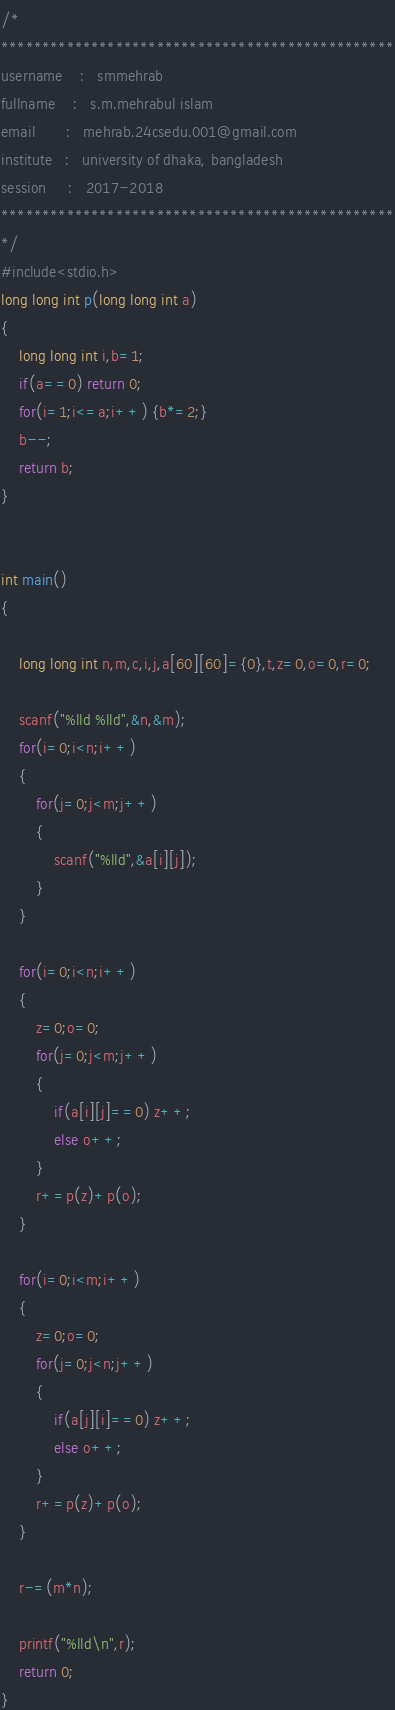Convert code to text. <code><loc_0><loc_0><loc_500><loc_500><_C_>/*
************************************************
username    :   smmehrab
fullname    :   s.m.mehrabul islam
email       :   mehrab.24csedu.001@gmail.com
institute   :   university of dhaka, bangladesh
session     :   2017-2018
************************************************
*/
#include<stdio.h>
long long int p(long long int a)
{
    long long int i,b=1;
    if(a==0) return 0;
    for(i=1;i<=a;i++) {b*=2;}
    b--;
    return b;
}


int main()
{

    long long int n,m,c,i,j,a[60][60]={0},t,z=0,o=0,r=0;

    scanf("%lld %lld",&n,&m);
    for(i=0;i<n;i++)
    {
        for(j=0;j<m;j++)
        {
            scanf("%lld",&a[i][j]);
        }
    }

    for(i=0;i<n;i++)
    {
        z=0;o=0;
        for(j=0;j<m;j++)
        {
            if(a[i][j]==0) z++;
            else o++;
        }
        r+=p(z)+p(o);
    }

    for(i=0;i<m;i++)
    {
        z=0;o=0;
        for(j=0;j<n;j++)
        {
            if(a[j][i]==0) z++;
            else o++;
        }
        r+=p(z)+p(o);
    }

    r-=(m*n);

    printf("%lld\n",r);
    return 0;
}
</code> 